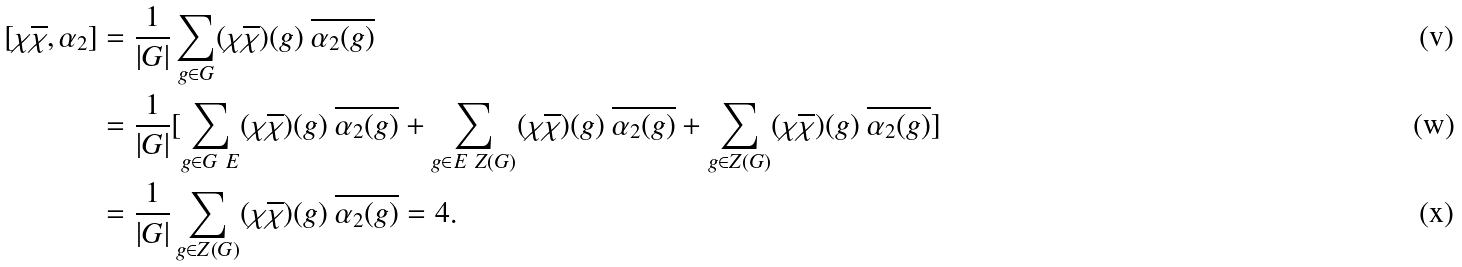Convert formula to latex. <formula><loc_0><loc_0><loc_500><loc_500>[ \chi \overline { \chi } , \alpha _ { 2 } ] & = \frac { 1 } { | G | } \sum _ { g \in G } ( \chi \overline { \chi } ) ( g ) \ \overline { \alpha _ { 2 } ( g ) } \\ & = \frac { 1 } { | G | } [ \sum _ { g \in G \ E } ( \chi \overline { \chi } ) ( g ) \ \overline { \alpha _ { 2 } ( g ) } + \sum _ { g \in E \ { Z } ( G ) } ( \chi \overline { \chi } ) ( g ) \ \overline { \alpha _ { 2 } ( g ) } + \sum _ { g \in { Z } ( G ) } ( \chi \overline { \chi } ) ( g ) \ \overline { \alpha _ { 2 } ( g ) } ] \\ & = \frac { 1 } { | G | } \sum _ { g \in { Z } ( G ) } ( \chi \overline { \chi } ) ( g ) \ \overline { \alpha _ { 2 } ( g ) } = 4 .</formula> 